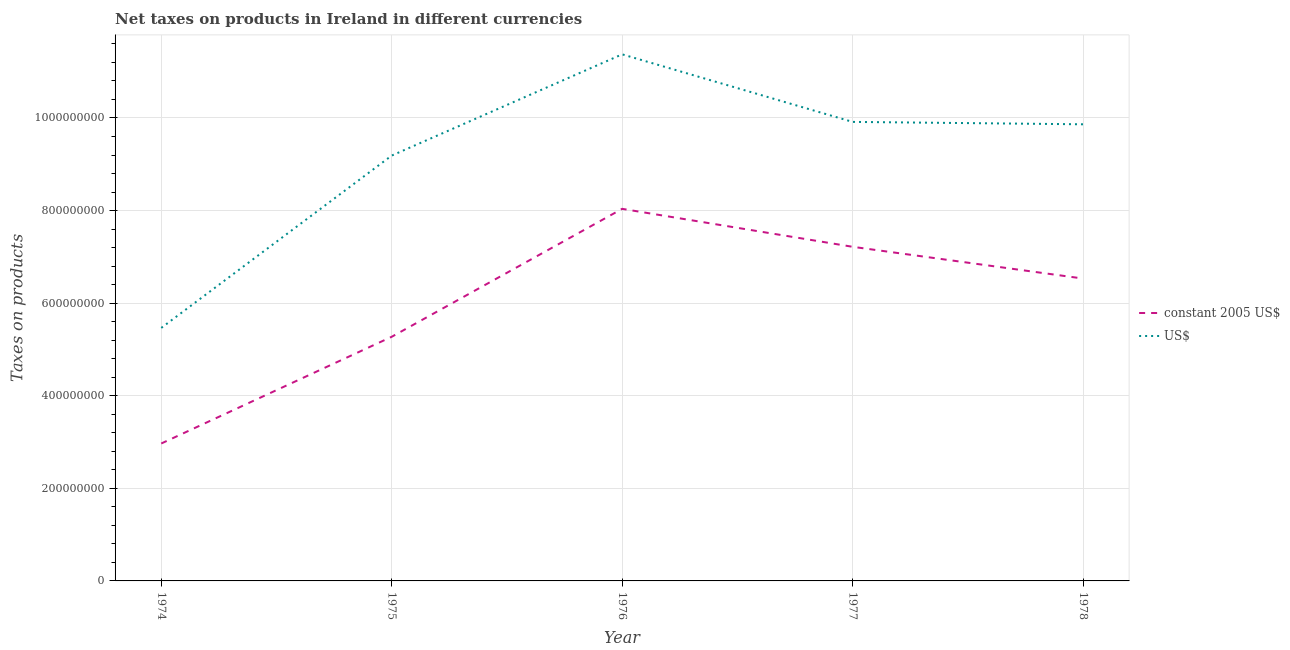What is the net taxes in us$ in 1975?
Provide a succinct answer. 9.19e+08. Across all years, what is the maximum net taxes in us$?
Provide a short and direct response. 1.14e+09. Across all years, what is the minimum net taxes in constant 2005 us$?
Make the answer very short. 2.97e+08. In which year was the net taxes in us$ maximum?
Provide a succinct answer. 1976. In which year was the net taxes in constant 2005 us$ minimum?
Make the answer very short. 1974. What is the total net taxes in us$ in the graph?
Provide a short and direct response. 4.58e+09. What is the difference between the net taxes in constant 2005 us$ in 1975 and that in 1976?
Provide a short and direct response. -2.76e+08. What is the difference between the net taxes in us$ in 1975 and the net taxes in constant 2005 us$ in 1977?
Provide a short and direct response. 1.97e+08. What is the average net taxes in us$ per year?
Your answer should be compact. 9.16e+08. In the year 1977, what is the difference between the net taxes in constant 2005 us$ and net taxes in us$?
Your response must be concise. -2.70e+08. In how many years, is the net taxes in us$ greater than 840000000 units?
Provide a short and direct response. 4. What is the ratio of the net taxes in us$ in 1975 to that in 1977?
Provide a succinct answer. 0.93. Is the difference between the net taxes in us$ in 1976 and 1977 greater than the difference between the net taxes in constant 2005 us$ in 1976 and 1977?
Your answer should be very brief. Yes. What is the difference between the highest and the second highest net taxes in us$?
Give a very brief answer. 1.46e+08. What is the difference between the highest and the lowest net taxes in us$?
Ensure brevity in your answer.  5.91e+08. Is the sum of the net taxes in constant 2005 us$ in 1976 and 1977 greater than the maximum net taxes in us$ across all years?
Your answer should be very brief. Yes. Does the net taxes in us$ monotonically increase over the years?
Your response must be concise. No. Is the net taxes in constant 2005 us$ strictly greater than the net taxes in us$ over the years?
Provide a succinct answer. No. Is the net taxes in constant 2005 us$ strictly less than the net taxes in us$ over the years?
Make the answer very short. Yes. How many lines are there?
Your answer should be very brief. 2. How many years are there in the graph?
Give a very brief answer. 5. What is the difference between two consecutive major ticks on the Y-axis?
Keep it short and to the point. 2.00e+08. Are the values on the major ticks of Y-axis written in scientific E-notation?
Make the answer very short. No. Does the graph contain any zero values?
Provide a short and direct response. No. Where does the legend appear in the graph?
Your answer should be compact. Center right. How are the legend labels stacked?
Give a very brief answer. Vertical. What is the title of the graph?
Your answer should be compact. Net taxes on products in Ireland in different currencies. Does "IMF concessional" appear as one of the legend labels in the graph?
Keep it short and to the point. No. What is the label or title of the Y-axis?
Offer a very short reply. Taxes on products. What is the Taxes on products of constant 2005 US$ in 1974?
Keep it short and to the point. 2.97e+08. What is the Taxes on products in US$ in 1974?
Offer a very short reply. 5.47e+08. What is the Taxes on products of constant 2005 US$ in 1975?
Make the answer very short. 5.27e+08. What is the Taxes on products of US$ in 1975?
Offer a very short reply. 9.19e+08. What is the Taxes on products in constant 2005 US$ in 1976?
Give a very brief answer. 8.04e+08. What is the Taxes on products in US$ in 1976?
Provide a succinct answer. 1.14e+09. What is the Taxes on products in constant 2005 US$ in 1977?
Offer a very short reply. 7.22e+08. What is the Taxes on products in US$ in 1977?
Your answer should be compact. 9.92e+08. What is the Taxes on products of constant 2005 US$ in 1978?
Provide a succinct answer. 6.53e+08. What is the Taxes on products of US$ in 1978?
Provide a succinct answer. 9.86e+08. Across all years, what is the maximum Taxes on products of constant 2005 US$?
Keep it short and to the point. 8.04e+08. Across all years, what is the maximum Taxes on products of US$?
Offer a terse response. 1.14e+09. Across all years, what is the minimum Taxes on products of constant 2005 US$?
Your answer should be very brief. 2.97e+08. Across all years, what is the minimum Taxes on products in US$?
Provide a short and direct response. 5.47e+08. What is the total Taxes on products of constant 2005 US$ in the graph?
Keep it short and to the point. 3.00e+09. What is the total Taxes on products in US$ in the graph?
Provide a short and direct response. 4.58e+09. What is the difference between the Taxes on products in constant 2005 US$ in 1974 and that in 1975?
Provide a short and direct response. -2.31e+08. What is the difference between the Taxes on products of US$ in 1974 and that in 1975?
Keep it short and to the point. -3.72e+08. What is the difference between the Taxes on products in constant 2005 US$ in 1974 and that in 1976?
Give a very brief answer. -5.07e+08. What is the difference between the Taxes on products in US$ in 1974 and that in 1976?
Offer a terse response. -5.91e+08. What is the difference between the Taxes on products in constant 2005 US$ in 1974 and that in 1977?
Make the answer very short. -4.25e+08. What is the difference between the Taxes on products in US$ in 1974 and that in 1977?
Make the answer very short. -4.45e+08. What is the difference between the Taxes on products in constant 2005 US$ in 1974 and that in 1978?
Your answer should be very brief. -3.56e+08. What is the difference between the Taxes on products in US$ in 1974 and that in 1978?
Make the answer very short. -4.40e+08. What is the difference between the Taxes on products in constant 2005 US$ in 1975 and that in 1976?
Keep it short and to the point. -2.76e+08. What is the difference between the Taxes on products in US$ in 1975 and that in 1976?
Offer a very short reply. -2.19e+08. What is the difference between the Taxes on products in constant 2005 US$ in 1975 and that in 1977?
Offer a terse response. -1.94e+08. What is the difference between the Taxes on products of US$ in 1975 and that in 1977?
Your response must be concise. -7.28e+07. What is the difference between the Taxes on products in constant 2005 US$ in 1975 and that in 1978?
Make the answer very short. -1.26e+08. What is the difference between the Taxes on products in US$ in 1975 and that in 1978?
Ensure brevity in your answer.  -6.76e+07. What is the difference between the Taxes on products of constant 2005 US$ in 1976 and that in 1977?
Your answer should be compact. 8.20e+07. What is the difference between the Taxes on products of US$ in 1976 and that in 1977?
Offer a very short reply. 1.46e+08. What is the difference between the Taxes on products in constant 2005 US$ in 1976 and that in 1978?
Provide a succinct answer. 1.51e+08. What is the difference between the Taxes on products of US$ in 1976 and that in 1978?
Your answer should be very brief. 1.51e+08. What is the difference between the Taxes on products in constant 2005 US$ in 1977 and that in 1978?
Provide a short and direct response. 6.86e+07. What is the difference between the Taxes on products in US$ in 1977 and that in 1978?
Ensure brevity in your answer.  5.19e+06. What is the difference between the Taxes on products in constant 2005 US$ in 1974 and the Taxes on products in US$ in 1975?
Give a very brief answer. -6.22e+08. What is the difference between the Taxes on products in constant 2005 US$ in 1974 and the Taxes on products in US$ in 1976?
Give a very brief answer. -8.41e+08. What is the difference between the Taxes on products in constant 2005 US$ in 1974 and the Taxes on products in US$ in 1977?
Offer a terse response. -6.95e+08. What is the difference between the Taxes on products of constant 2005 US$ in 1974 and the Taxes on products of US$ in 1978?
Make the answer very short. -6.90e+08. What is the difference between the Taxes on products of constant 2005 US$ in 1975 and the Taxes on products of US$ in 1976?
Provide a short and direct response. -6.10e+08. What is the difference between the Taxes on products of constant 2005 US$ in 1975 and the Taxes on products of US$ in 1977?
Provide a short and direct response. -4.64e+08. What is the difference between the Taxes on products in constant 2005 US$ in 1975 and the Taxes on products in US$ in 1978?
Offer a very short reply. -4.59e+08. What is the difference between the Taxes on products of constant 2005 US$ in 1976 and the Taxes on products of US$ in 1977?
Ensure brevity in your answer.  -1.88e+08. What is the difference between the Taxes on products of constant 2005 US$ in 1976 and the Taxes on products of US$ in 1978?
Provide a succinct answer. -1.83e+08. What is the difference between the Taxes on products of constant 2005 US$ in 1977 and the Taxes on products of US$ in 1978?
Make the answer very short. -2.65e+08. What is the average Taxes on products in constant 2005 US$ per year?
Make the answer very short. 6.01e+08. What is the average Taxes on products of US$ per year?
Your response must be concise. 9.16e+08. In the year 1974, what is the difference between the Taxes on products of constant 2005 US$ and Taxes on products of US$?
Provide a short and direct response. -2.50e+08. In the year 1975, what is the difference between the Taxes on products in constant 2005 US$ and Taxes on products in US$?
Your answer should be very brief. -3.91e+08. In the year 1976, what is the difference between the Taxes on products of constant 2005 US$ and Taxes on products of US$?
Provide a succinct answer. -3.34e+08. In the year 1977, what is the difference between the Taxes on products of constant 2005 US$ and Taxes on products of US$?
Your response must be concise. -2.70e+08. In the year 1978, what is the difference between the Taxes on products of constant 2005 US$ and Taxes on products of US$?
Keep it short and to the point. -3.33e+08. What is the ratio of the Taxes on products of constant 2005 US$ in 1974 to that in 1975?
Your answer should be compact. 0.56. What is the ratio of the Taxes on products of US$ in 1974 to that in 1975?
Offer a terse response. 0.59. What is the ratio of the Taxes on products of constant 2005 US$ in 1974 to that in 1976?
Your answer should be compact. 0.37. What is the ratio of the Taxes on products of US$ in 1974 to that in 1976?
Your answer should be compact. 0.48. What is the ratio of the Taxes on products of constant 2005 US$ in 1974 to that in 1977?
Ensure brevity in your answer.  0.41. What is the ratio of the Taxes on products of US$ in 1974 to that in 1977?
Give a very brief answer. 0.55. What is the ratio of the Taxes on products of constant 2005 US$ in 1974 to that in 1978?
Offer a very short reply. 0.45. What is the ratio of the Taxes on products of US$ in 1974 to that in 1978?
Your answer should be very brief. 0.55. What is the ratio of the Taxes on products of constant 2005 US$ in 1975 to that in 1976?
Provide a short and direct response. 0.66. What is the ratio of the Taxes on products of US$ in 1975 to that in 1976?
Your answer should be compact. 0.81. What is the ratio of the Taxes on products of constant 2005 US$ in 1975 to that in 1977?
Ensure brevity in your answer.  0.73. What is the ratio of the Taxes on products of US$ in 1975 to that in 1977?
Ensure brevity in your answer.  0.93. What is the ratio of the Taxes on products in constant 2005 US$ in 1975 to that in 1978?
Ensure brevity in your answer.  0.81. What is the ratio of the Taxes on products of US$ in 1975 to that in 1978?
Ensure brevity in your answer.  0.93. What is the ratio of the Taxes on products in constant 2005 US$ in 1976 to that in 1977?
Give a very brief answer. 1.11. What is the ratio of the Taxes on products in US$ in 1976 to that in 1977?
Keep it short and to the point. 1.15. What is the ratio of the Taxes on products in constant 2005 US$ in 1976 to that in 1978?
Provide a succinct answer. 1.23. What is the ratio of the Taxes on products of US$ in 1976 to that in 1978?
Provide a succinct answer. 1.15. What is the ratio of the Taxes on products in constant 2005 US$ in 1977 to that in 1978?
Your answer should be very brief. 1.1. What is the difference between the highest and the second highest Taxes on products of constant 2005 US$?
Make the answer very short. 8.20e+07. What is the difference between the highest and the second highest Taxes on products in US$?
Ensure brevity in your answer.  1.46e+08. What is the difference between the highest and the lowest Taxes on products in constant 2005 US$?
Provide a succinct answer. 5.07e+08. What is the difference between the highest and the lowest Taxes on products of US$?
Give a very brief answer. 5.91e+08. 